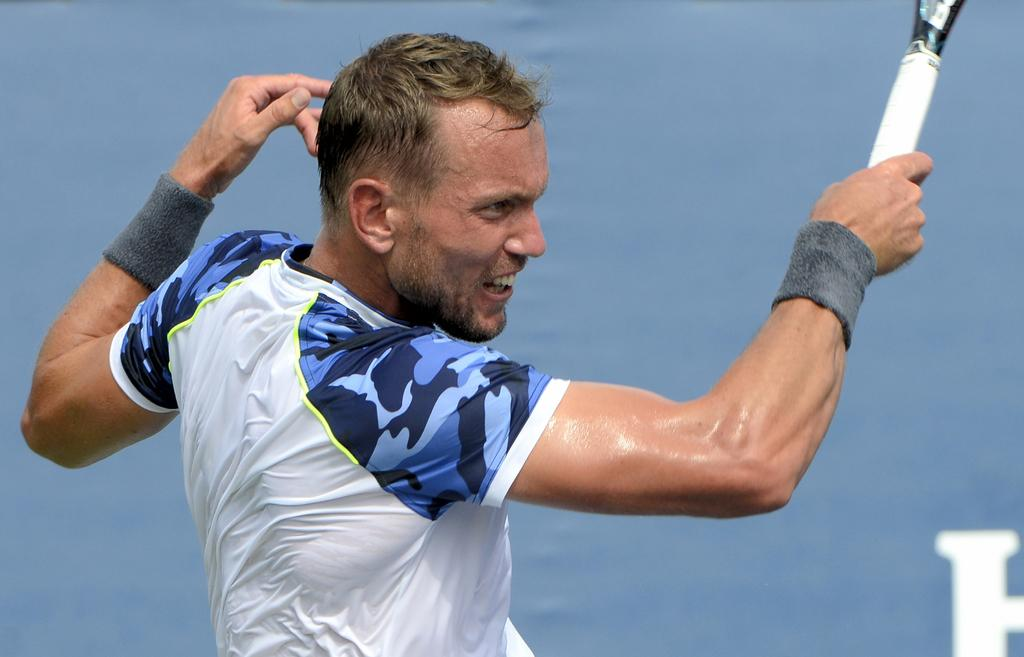What is the main subject of the image? There is a man in the image. What is the man doing in the image? The man is in motion, and he is holding a racket. What color is the background of the image? The background of the image is blue. What type of horn can be seen on the man's head in the image? There is no horn present on the man's head in the image. What type of cabbage is the man holding in the image? The man is holding a racket, not a cabbage, in the image. 